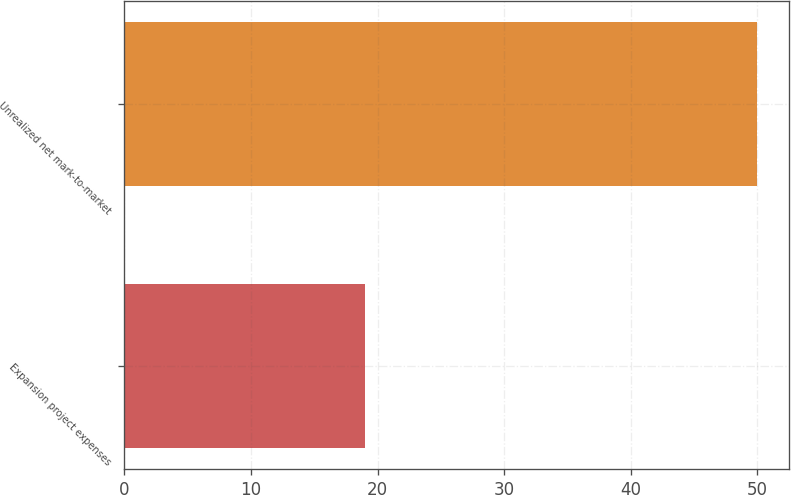<chart> <loc_0><loc_0><loc_500><loc_500><bar_chart><fcel>Expansion project expenses<fcel>Unrealized net mark-to-market<nl><fcel>19<fcel>50<nl></chart> 